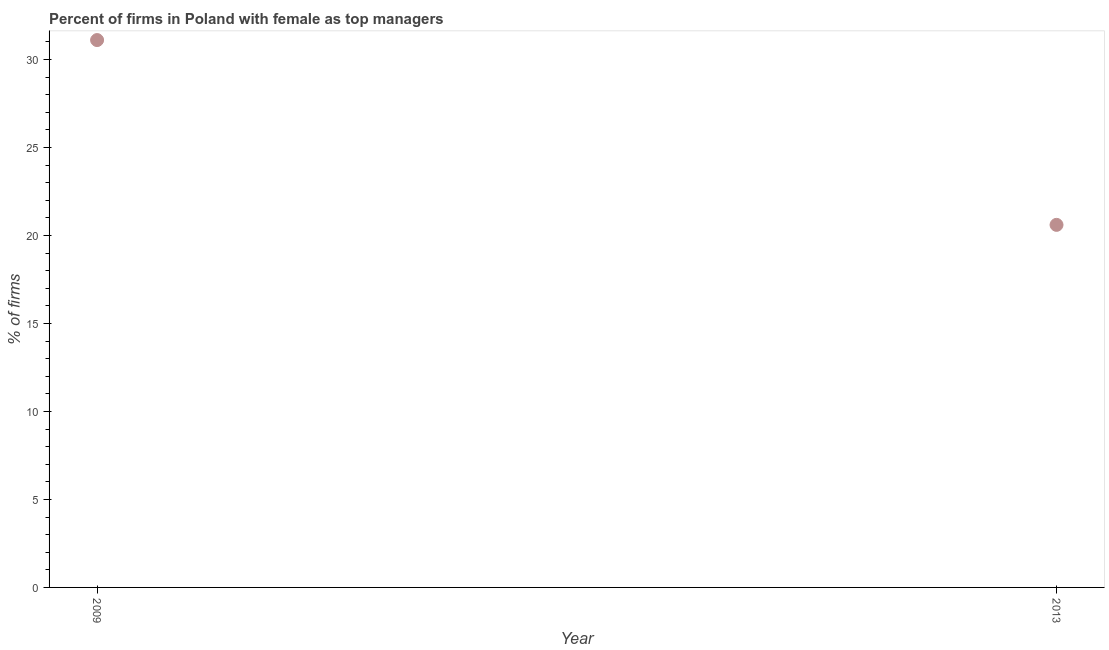What is the percentage of firms with female as top manager in 2013?
Ensure brevity in your answer.  20.6. Across all years, what is the maximum percentage of firms with female as top manager?
Give a very brief answer. 31.1. Across all years, what is the minimum percentage of firms with female as top manager?
Offer a very short reply. 20.6. In which year was the percentage of firms with female as top manager minimum?
Make the answer very short. 2013. What is the sum of the percentage of firms with female as top manager?
Provide a short and direct response. 51.7. What is the difference between the percentage of firms with female as top manager in 2009 and 2013?
Offer a very short reply. 10.5. What is the average percentage of firms with female as top manager per year?
Your answer should be compact. 25.85. What is the median percentage of firms with female as top manager?
Provide a succinct answer. 25.85. In how many years, is the percentage of firms with female as top manager greater than 22 %?
Your answer should be compact. 1. Do a majority of the years between 2009 and 2013 (inclusive) have percentage of firms with female as top manager greater than 2 %?
Offer a very short reply. Yes. What is the ratio of the percentage of firms with female as top manager in 2009 to that in 2013?
Provide a short and direct response. 1.51. Is the percentage of firms with female as top manager in 2009 less than that in 2013?
Your answer should be compact. No. In how many years, is the percentage of firms with female as top manager greater than the average percentage of firms with female as top manager taken over all years?
Your answer should be compact. 1. How many years are there in the graph?
Your answer should be very brief. 2. What is the difference between two consecutive major ticks on the Y-axis?
Your answer should be compact. 5. Does the graph contain grids?
Provide a short and direct response. No. What is the title of the graph?
Provide a succinct answer. Percent of firms in Poland with female as top managers. What is the label or title of the Y-axis?
Provide a succinct answer. % of firms. What is the % of firms in 2009?
Your answer should be compact. 31.1. What is the % of firms in 2013?
Your answer should be compact. 20.6. What is the ratio of the % of firms in 2009 to that in 2013?
Provide a succinct answer. 1.51. 